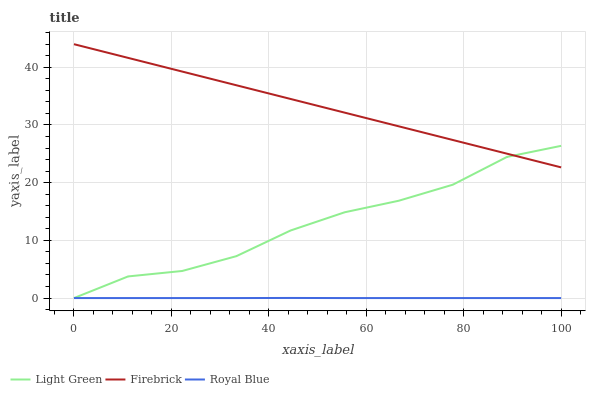Does Light Green have the minimum area under the curve?
Answer yes or no. No. Does Light Green have the maximum area under the curve?
Answer yes or no. No. Is Light Green the smoothest?
Answer yes or no. No. Is Firebrick the roughest?
Answer yes or no. No. Does Firebrick have the lowest value?
Answer yes or no. No. Does Light Green have the highest value?
Answer yes or no. No. Is Royal Blue less than Firebrick?
Answer yes or no. Yes. Is Firebrick greater than Royal Blue?
Answer yes or no. Yes. Does Royal Blue intersect Firebrick?
Answer yes or no. No. 